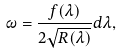Convert formula to latex. <formula><loc_0><loc_0><loc_500><loc_500>\omega = \frac { f ( \lambda ) } { 2 \sqrt { R ( \lambda ) } } d \lambda ,</formula> 